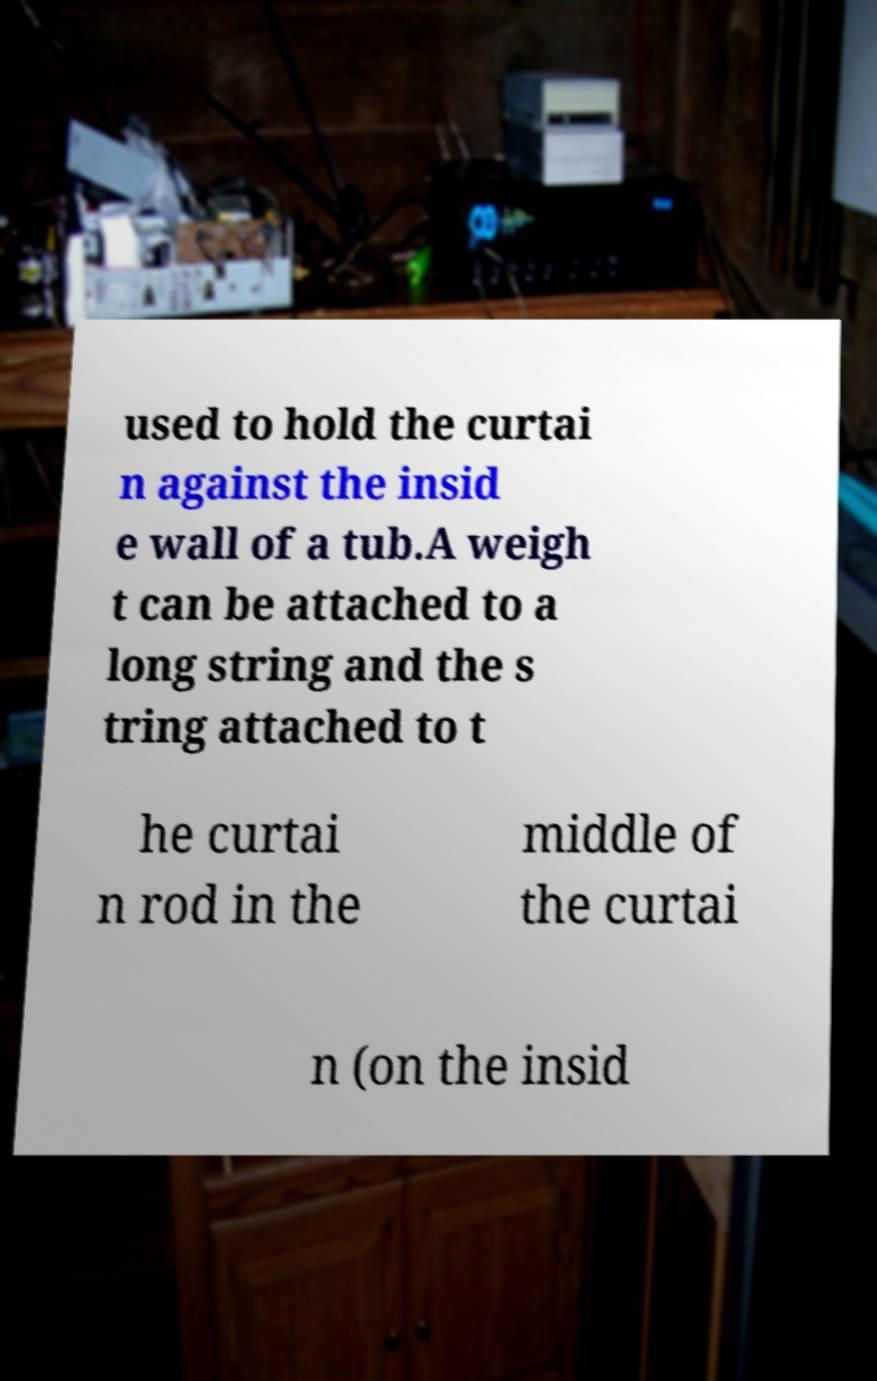What messages or text are displayed in this image? I need them in a readable, typed format. used to hold the curtai n against the insid e wall of a tub.A weigh t can be attached to a long string and the s tring attached to t he curtai n rod in the middle of the curtai n (on the insid 